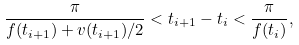Convert formula to latex. <formula><loc_0><loc_0><loc_500><loc_500>\frac { \pi } { f ( t _ { i + 1 } ) + v ( t _ { i + 1 } ) / 2 } < t _ { i + 1 } - t _ { i } < \frac { \pi } { f ( t _ { i } ) } ,</formula> 